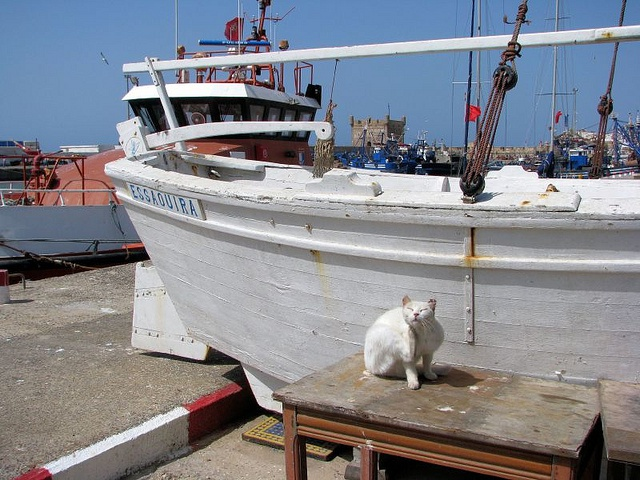Describe the objects in this image and their specific colors. I can see boat in gray, darkgray, and lightgray tones, dining table in gray, darkgray, and black tones, cat in gray, lightgray, darkgray, and black tones, and dining table in gray and darkgray tones in this image. 